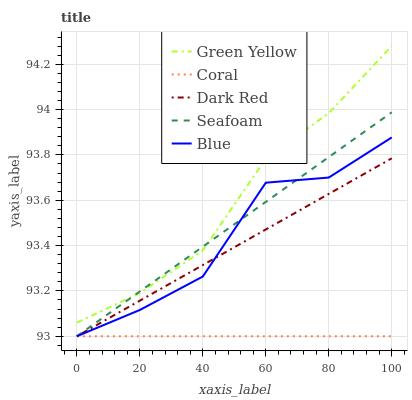Does Coral have the minimum area under the curve?
Answer yes or no. Yes. Does Green Yellow have the maximum area under the curve?
Answer yes or no. Yes. Does Dark Red have the minimum area under the curve?
Answer yes or no. No. Does Dark Red have the maximum area under the curve?
Answer yes or no. No. Is Coral the smoothest?
Answer yes or no. Yes. Is Blue the roughest?
Answer yes or no. Yes. Is Dark Red the smoothest?
Answer yes or no. No. Is Dark Red the roughest?
Answer yes or no. No. Does Blue have the lowest value?
Answer yes or no. Yes. Does Green Yellow have the lowest value?
Answer yes or no. No. Does Green Yellow have the highest value?
Answer yes or no. Yes. Does Dark Red have the highest value?
Answer yes or no. No. Is Dark Red less than Green Yellow?
Answer yes or no. Yes. Is Green Yellow greater than Dark Red?
Answer yes or no. Yes. Does Dark Red intersect Blue?
Answer yes or no. Yes. Is Dark Red less than Blue?
Answer yes or no. No. Is Dark Red greater than Blue?
Answer yes or no. No. Does Dark Red intersect Green Yellow?
Answer yes or no. No. 